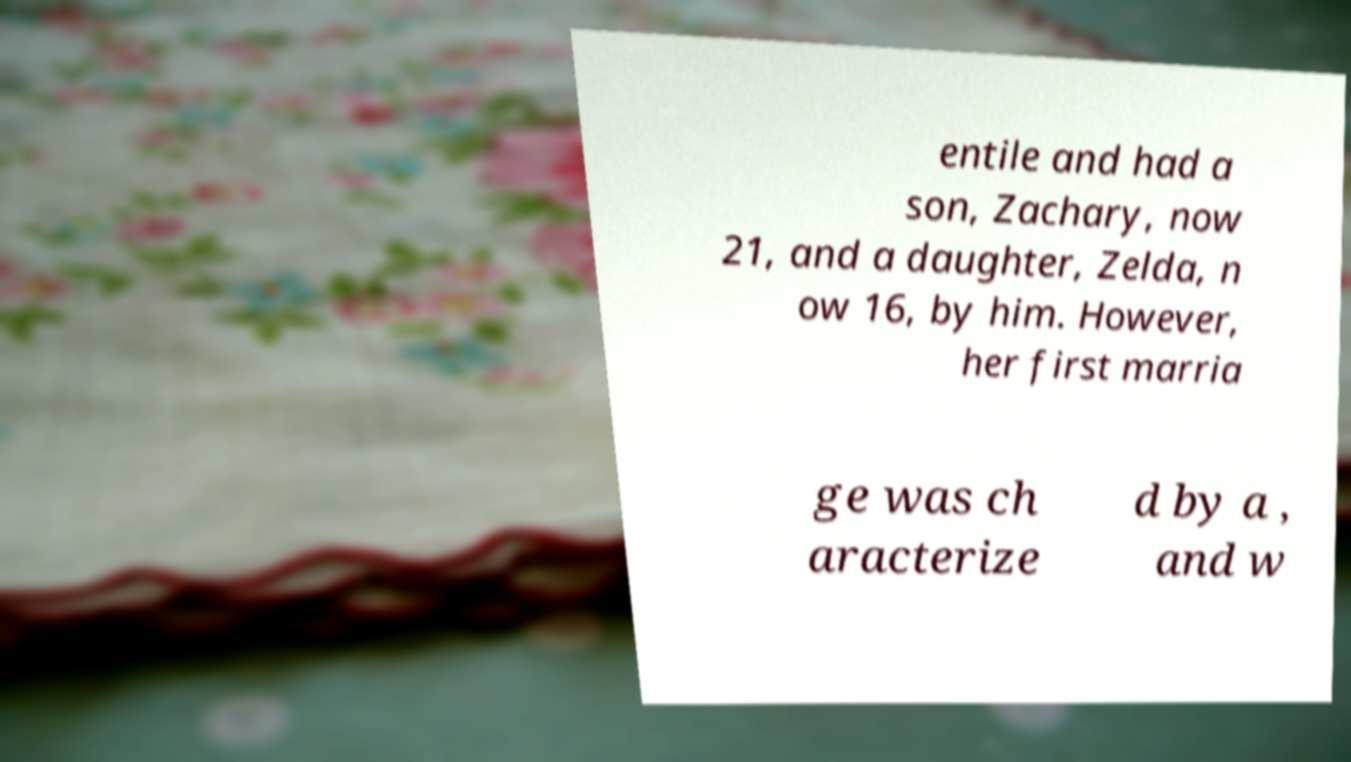Can you read and provide the text displayed in the image?This photo seems to have some interesting text. Can you extract and type it out for me? entile and had a son, Zachary, now 21, and a daughter, Zelda, n ow 16, by him. However, her first marria ge was ch aracterize d by a , and w 